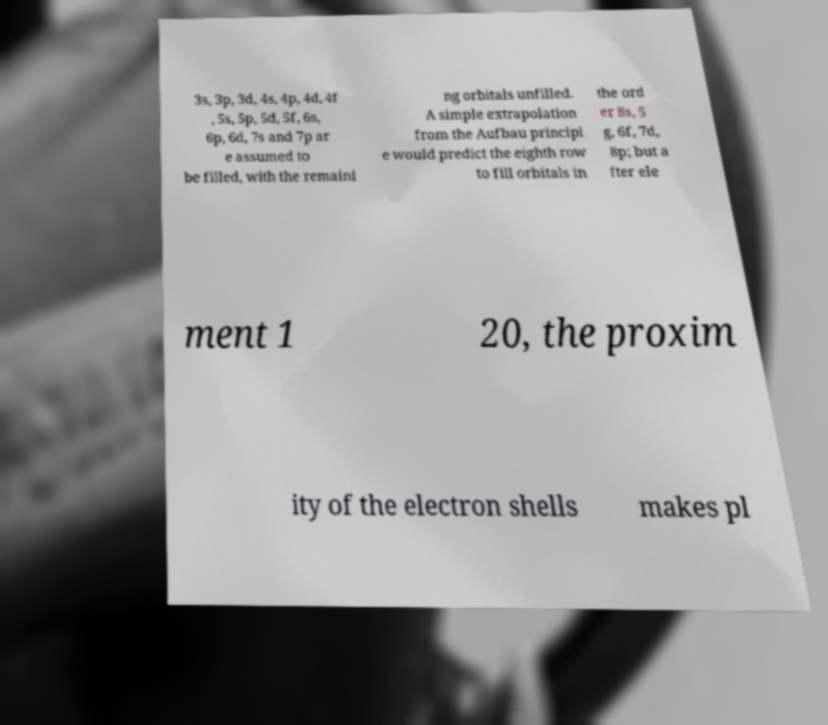I need the written content from this picture converted into text. Can you do that? 3s, 3p, 3d, 4s, 4p, 4d, 4f , 5s, 5p, 5d, 5f, 6s, 6p, 6d, 7s and 7p ar e assumed to be filled, with the remaini ng orbitals unfilled. A simple extrapolation from the Aufbau principl e would predict the eighth row to fill orbitals in the ord er 8s, 5 g, 6f, 7d, 8p; but a fter ele ment 1 20, the proxim ity of the electron shells makes pl 